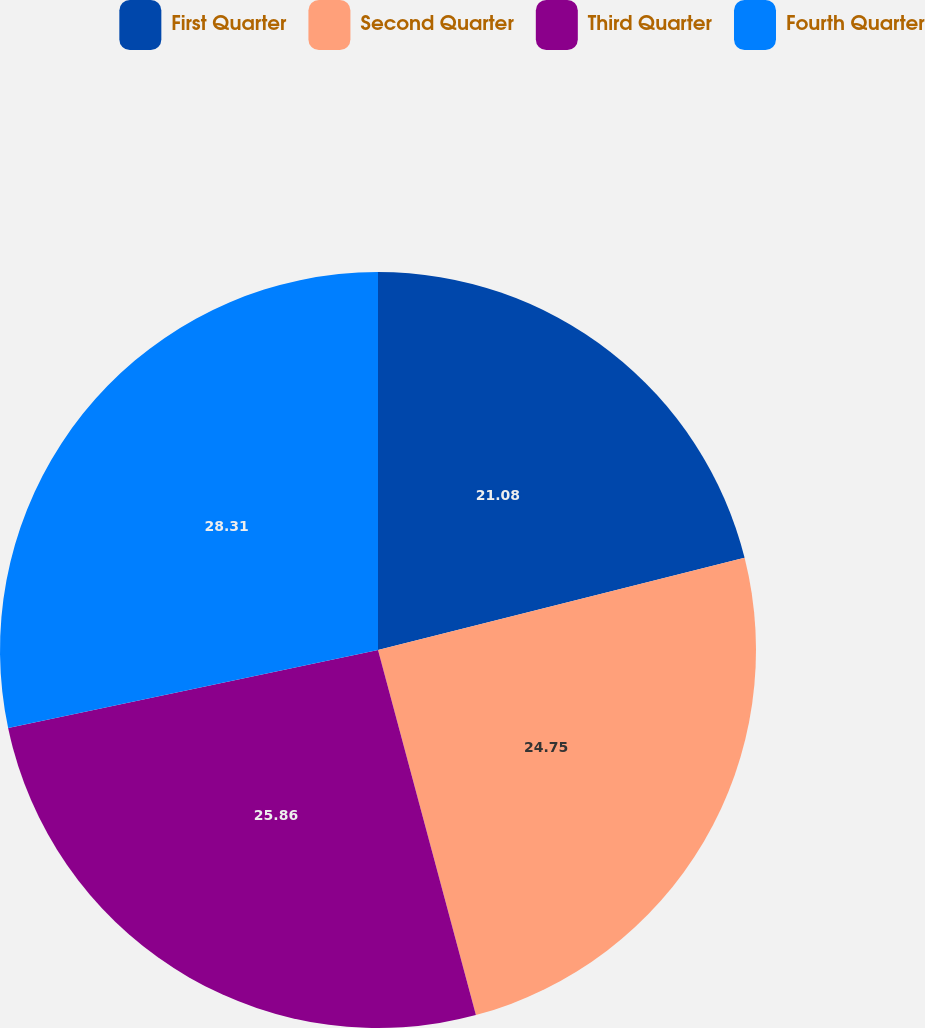<chart> <loc_0><loc_0><loc_500><loc_500><pie_chart><fcel>First Quarter<fcel>Second Quarter<fcel>Third Quarter<fcel>Fourth Quarter<nl><fcel>21.08%<fcel>24.75%<fcel>25.86%<fcel>28.31%<nl></chart> 